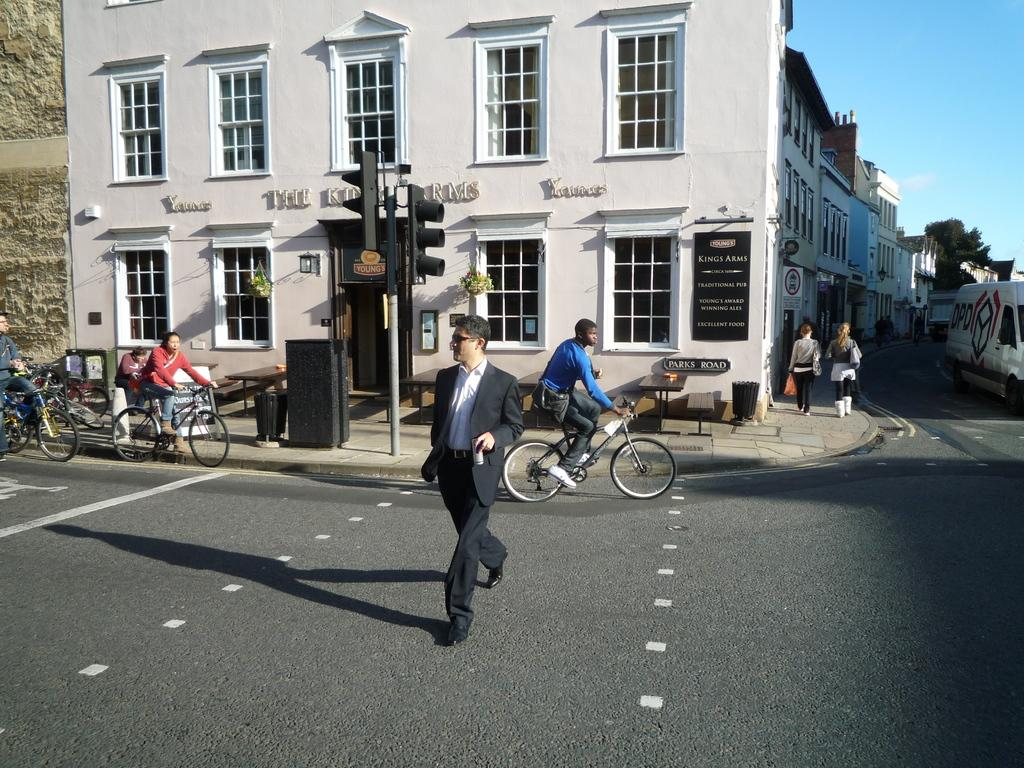What is happening in the background of the image? In the background, there is a man walking on the road and people riding bicycles. What can be seen in the image besides the people and the road? There is a traffic pole and a building in the image. What are the two women in the image doing? The two women are walking on a pathway. What is visible in the sky in the image? The sky is visible in the image. What type of beef is being served at the restaurant in the image? There is no restaurant or beef present in the image. How many trees are visible in the image? There are no trees visible in the image. 